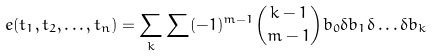<formula> <loc_0><loc_0><loc_500><loc_500>e ( t _ { 1 } , t _ { 2 } , \dots , t _ { n } ) = \sum _ { k } \sum ( - 1 ) ^ { m - 1 } \binom { k - 1 } { m - 1 } b _ { 0 } \delta b _ { 1 } \delta \dots \delta b _ { k }</formula> 